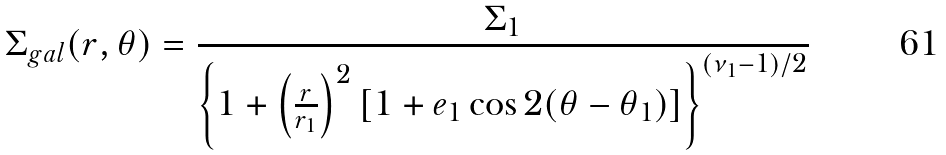Convert formula to latex. <formula><loc_0><loc_0><loc_500><loc_500>\Sigma _ { g a l } ( r , \theta ) = \frac { \Sigma _ { 1 } } { \left \{ 1 + \left ( \frac { r } { r _ { 1 } } \right ) ^ { 2 } [ 1 + e _ { 1 } \cos 2 ( \theta - \theta _ { 1 } ) ] \right \} ^ { ( \nu _ { 1 } - 1 ) / 2 } }</formula> 